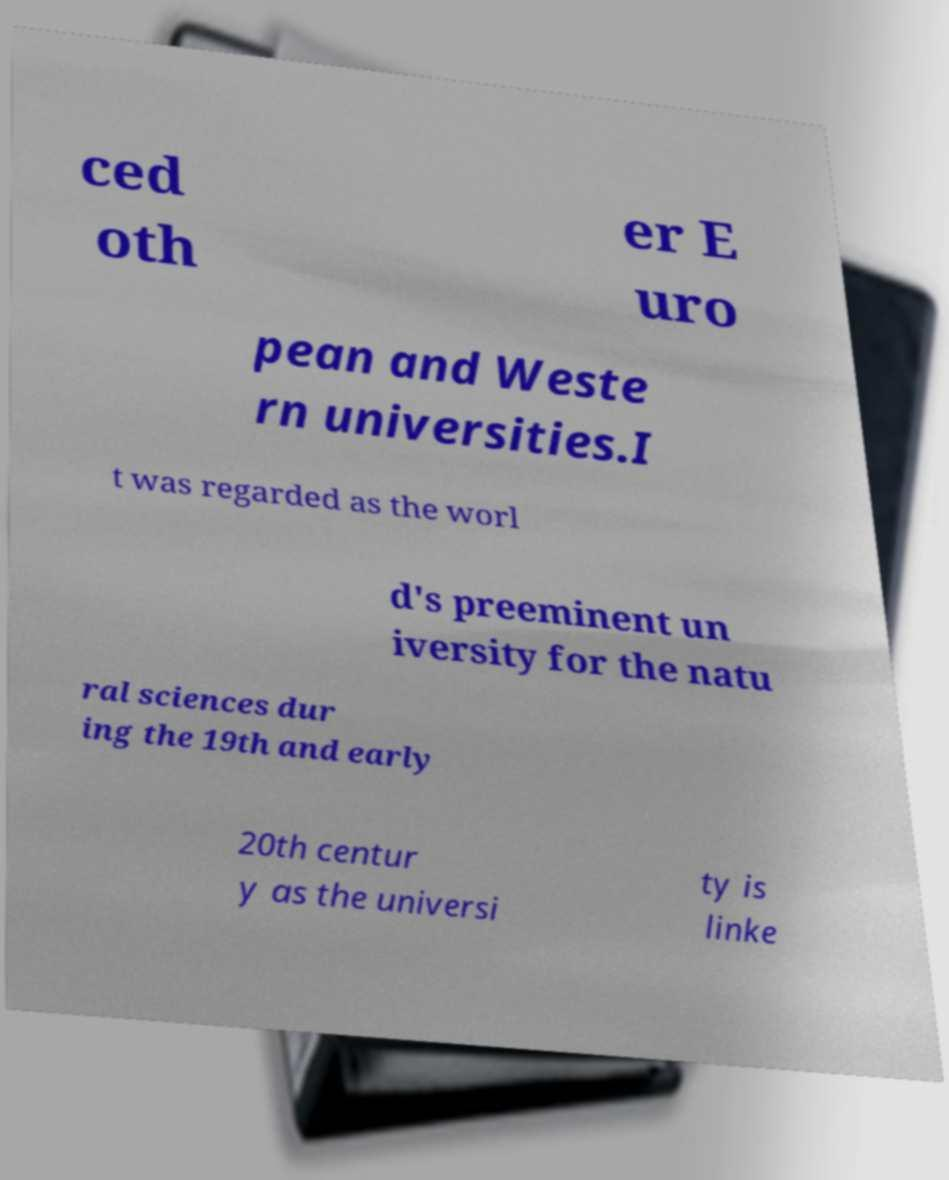Please read and relay the text visible in this image. What does it say? ced oth er E uro pean and Weste rn universities.I t was regarded as the worl d's preeminent un iversity for the natu ral sciences dur ing the 19th and early 20th centur y as the universi ty is linke 